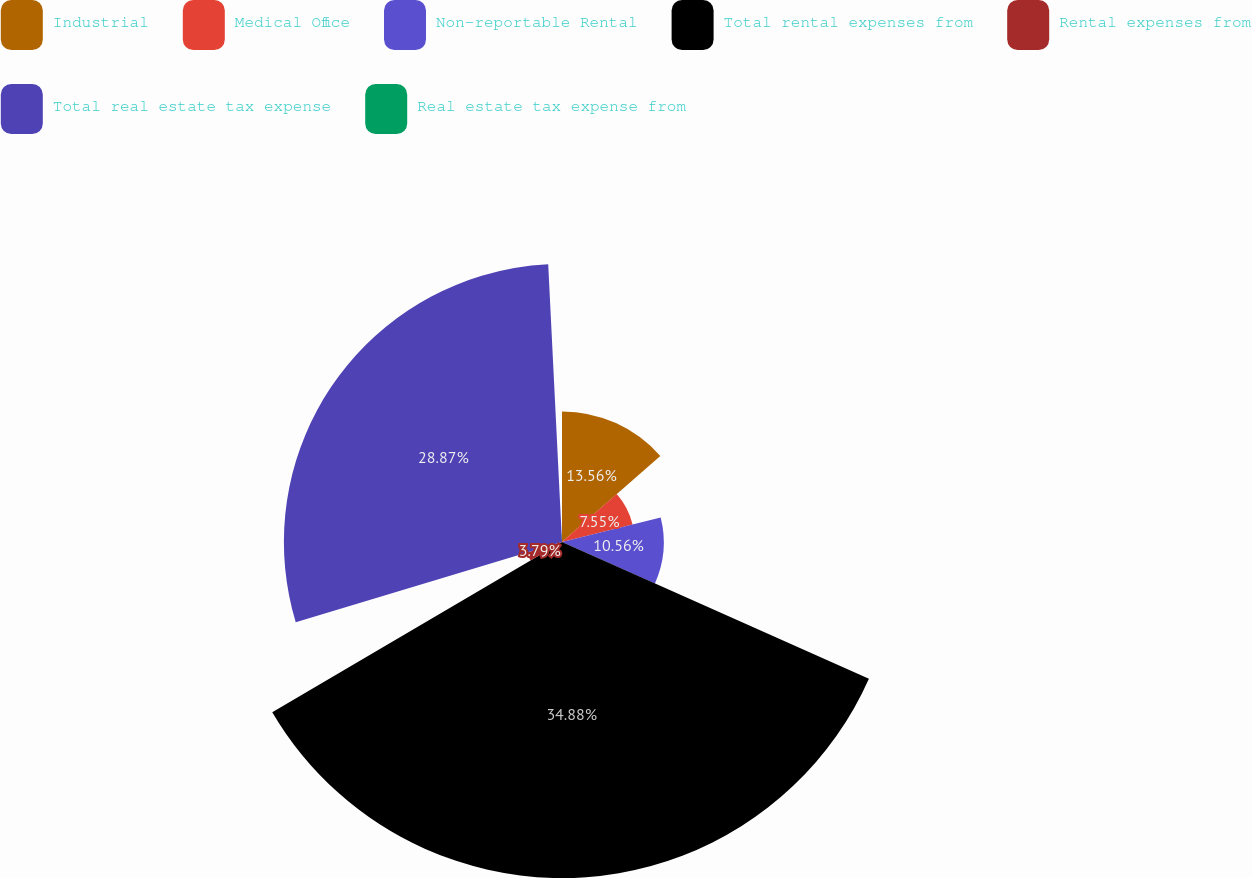Convert chart. <chart><loc_0><loc_0><loc_500><loc_500><pie_chart><fcel>Industrial<fcel>Medical Office<fcel>Non-reportable Rental<fcel>Total rental expenses from<fcel>Rental expenses from<fcel>Total real estate tax expense<fcel>Real estate tax expense from<nl><fcel>13.56%<fcel>7.55%<fcel>10.56%<fcel>34.88%<fcel>3.79%<fcel>28.87%<fcel>0.79%<nl></chart> 